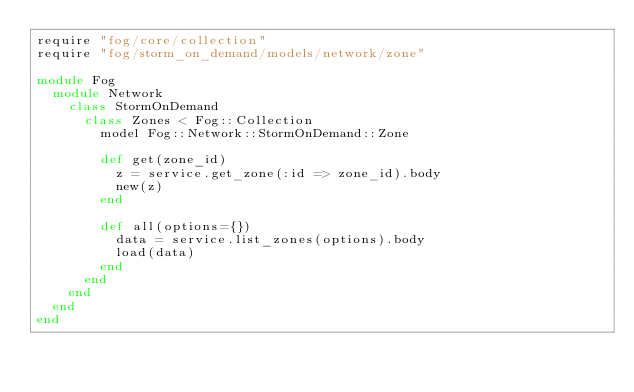Convert code to text. <code><loc_0><loc_0><loc_500><loc_500><_Ruby_>require "fog/core/collection"
require "fog/storm_on_demand/models/network/zone"

module Fog
  module Network
    class StormOnDemand
      class Zones < Fog::Collection
        model Fog::Network::StormOnDemand::Zone

        def get(zone_id)
          z = service.get_zone(:id => zone_id).body
          new(z)
        end

        def all(options={})
          data = service.list_zones(options).body
          load(data)
        end
      end
    end
  end
end
</code> 